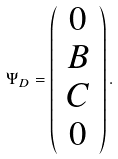Convert formula to latex. <formula><loc_0><loc_0><loc_500><loc_500>\Psi _ { D } = \left ( \begin{array} { c } 0 \\ B \\ C \\ 0 \end{array} \right ) .</formula> 